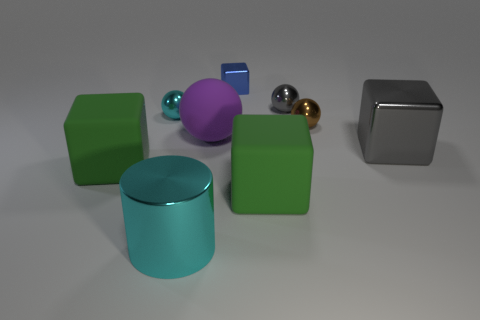What is the color of the big matte ball?
Give a very brief answer. Purple. There is a big gray metal block; are there any big purple spheres on the left side of it?
Offer a very short reply. Yes. Do the big shiny block and the cylinder have the same color?
Keep it short and to the point. No. How many metallic blocks have the same color as the large rubber ball?
Make the answer very short. 0. How big is the gray shiny object in front of the small thing to the left of the big cylinder?
Offer a very short reply. Large. What shape is the blue metallic object?
Provide a succinct answer. Cube. There is a block on the right side of the small gray metallic object; what is it made of?
Provide a short and direct response. Metal. What color is the large shiny thing that is in front of the large green object that is on the left side of the matte block to the right of the large purple matte thing?
Provide a succinct answer. Cyan. There is a block that is the same size as the brown sphere; what is its color?
Provide a succinct answer. Blue. How many metal objects are either blue blocks or green things?
Your response must be concise. 1. 